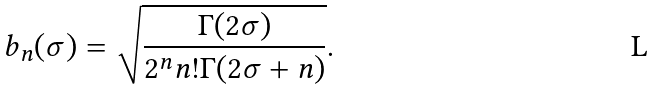Convert formula to latex. <formula><loc_0><loc_0><loc_500><loc_500>b _ { n } ( \sigma ) = \sqrt { \frac { \Gamma ( 2 \sigma ) } { 2 ^ { n } n ! \Gamma ( 2 \sigma + n ) } } .</formula> 